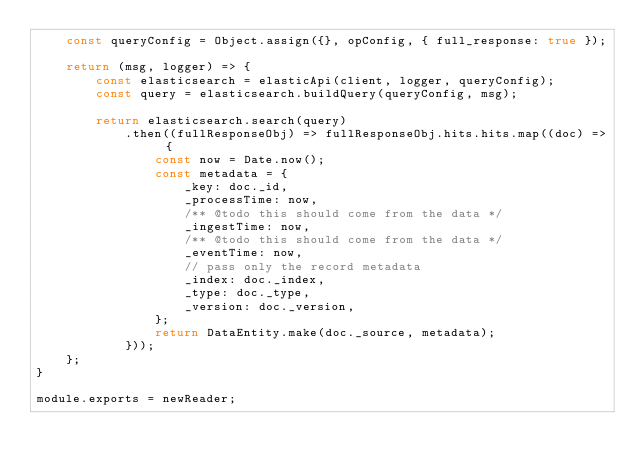<code> <loc_0><loc_0><loc_500><loc_500><_JavaScript_>    const queryConfig = Object.assign({}, opConfig, { full_response: true });

    return (msg, logger) => {
        const elasticsearch = elasticApi(client, logger, queryConfig);
        const query = elasticsearch.buildQuery(queryConfig, msg);

        return elasticsearch.search(query)
            .then((fullResponseObj) => fullResponseObj.hits.hits.map((doc) => {
                const now = Date.now();
                const metadata = {
                    _key: doc._id,
                    _processTime: now,
                    /** @todo this should come from the data */
                    _ingestTime: now,
                    /** @todo this should come from the data */
                    _eventTime: now,
                    // pass only the record metadata
                    _index: doc._index,
                    _type: doc._type,
                    _version: doc._version,
                };
                return DataEntity.make(doc._source, metadata);
            }));
    };
}

module.exports = newReader;
</code> 